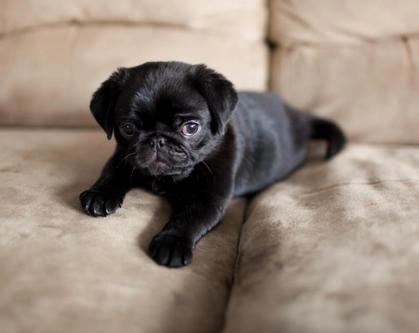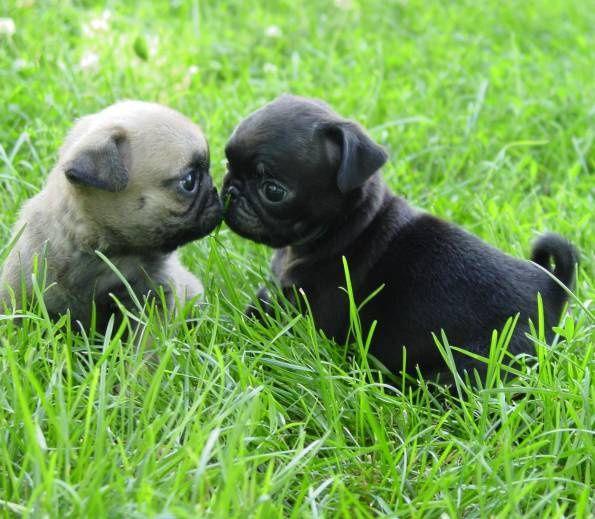The first image is the image on the left, the second image is the image on the right. Evaluate the accuracy of this statement regarding the images: "Two dogs are sitting in the grass in one of the images.". Is it true? Answer yes or no. Yes. The first image is the image on the left, the second image is the image on the right. Examine the images to the left and right. Is the description "There are exactly two dogs on the grass in the image on the right." accurate? Answer yes or no. Yes. 